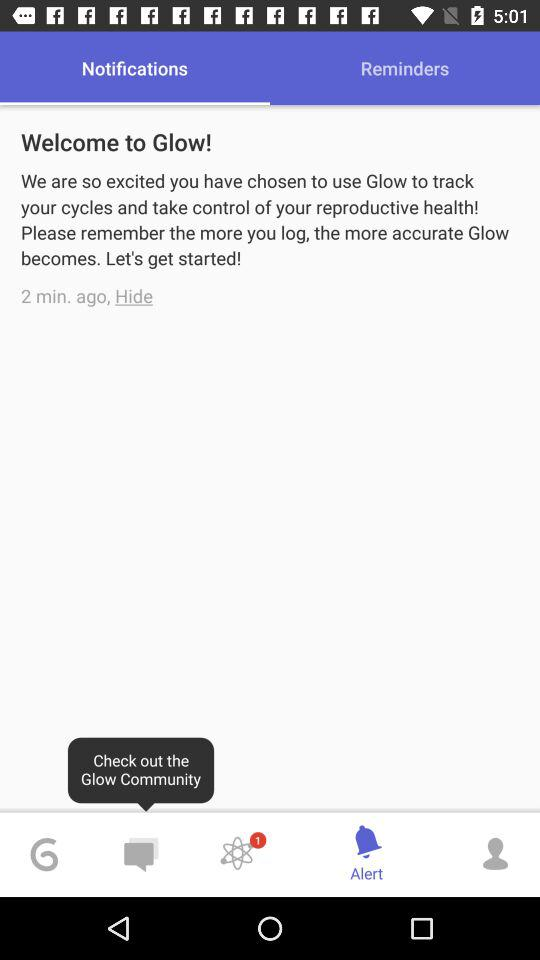Which tab is selected? The selected tabs are "Notifications" and "Alert". 